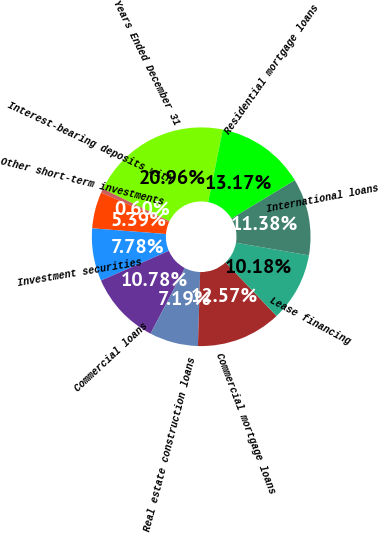Convert chart. <chart><loc_0><loc_0><loc_500><loc_500><pie_chart><fcel>Years Ended December 31<fcel>Interest-bearing deposits with<fcel>Other short-term investments<fcel>Investment securities<fcel>Commercial loans<fcel>Real estate construction loans<fcel>Commercial mortgage loans<fcel>Lease financing<fcel>International loans<fcel>Residential mortgage loans<nl><fcel>20.96%<fcel>0.6%<fcel>5.39%<fcel>7.78%<fcel>10.78%<fcel>7.19%<fcel>12.57%<fcel>10.18%<fcel>11.38%<fcel>13.17%<nl></chart> 